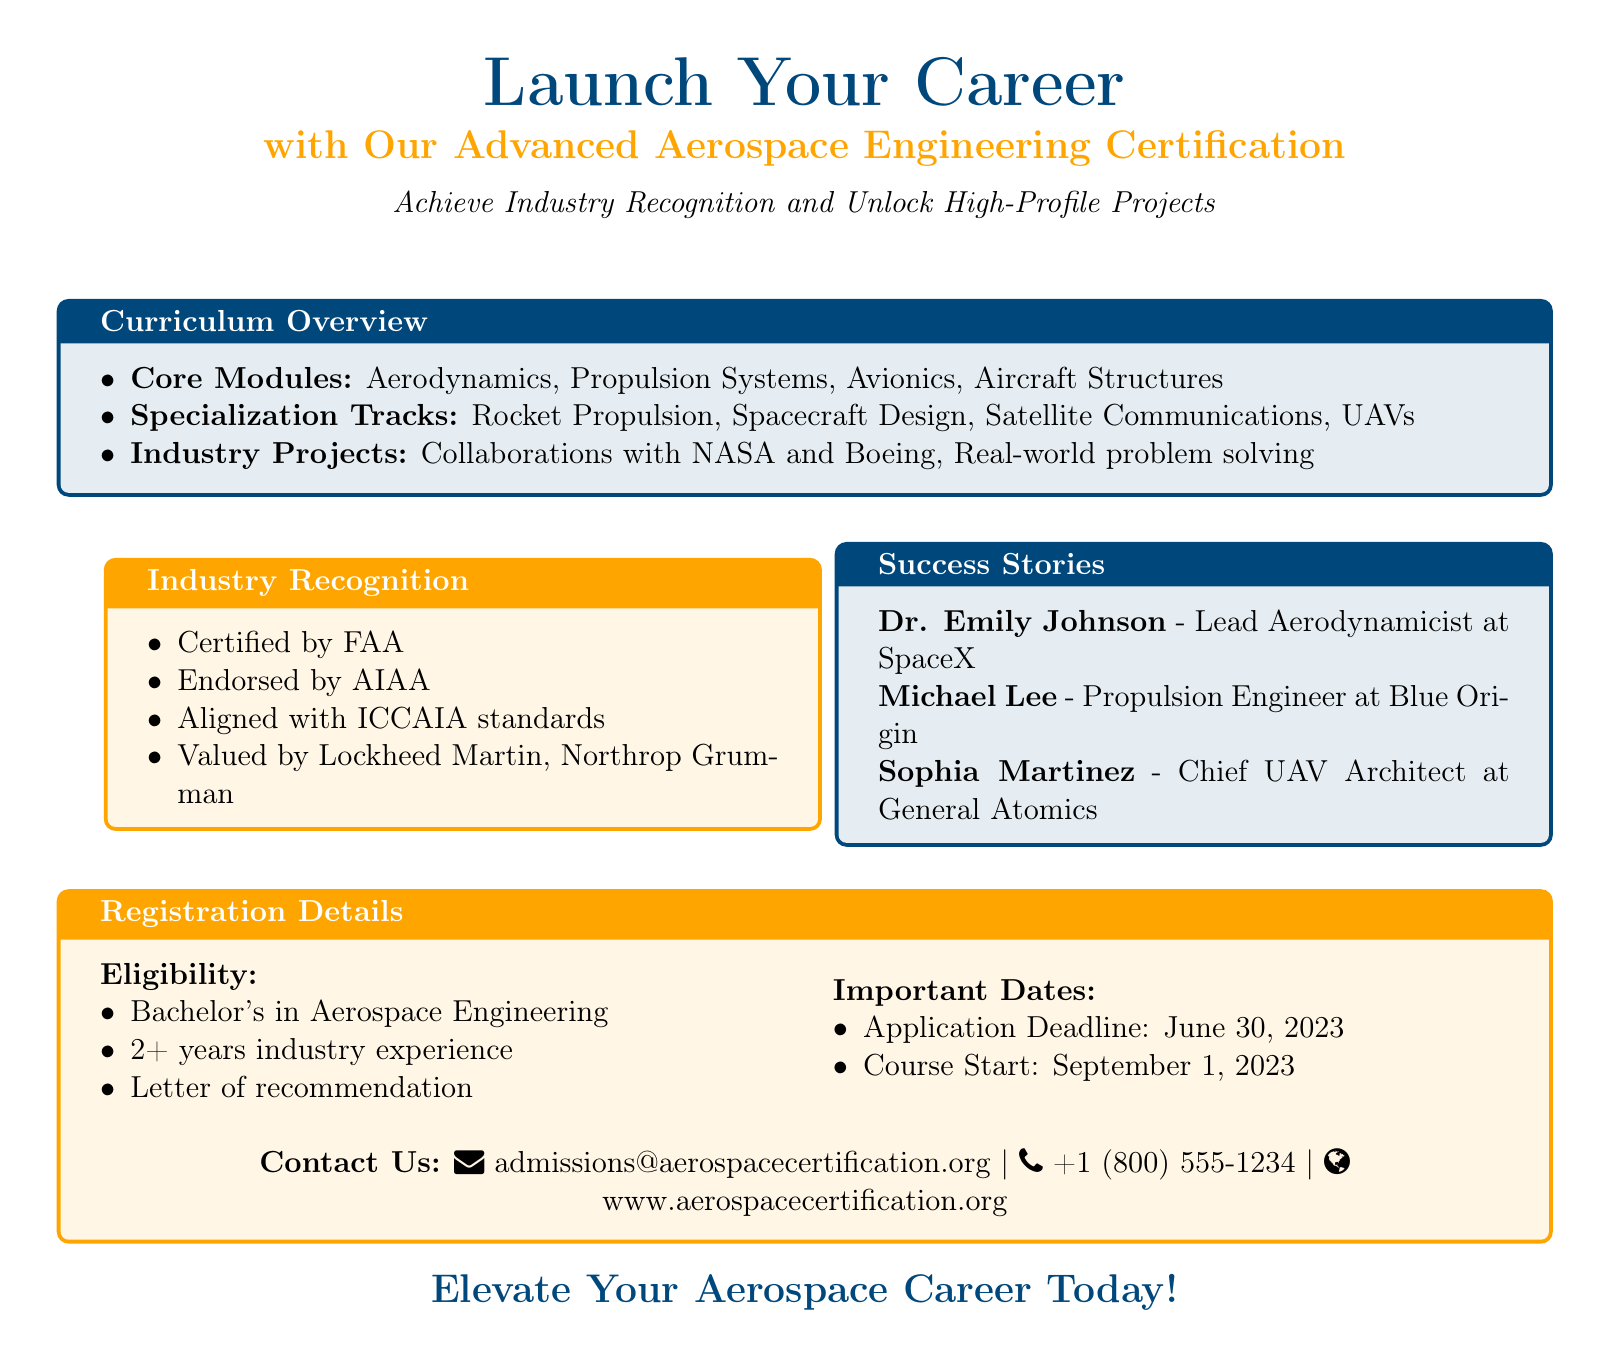What are the core modules included in the curriculum? The core modules are listed under the curriculum overview section of the document.
Answer: Aerodynamics, Propulsion Systems, Avionics, Aircraft Structures Who is a success story mentioned in the advertisement? The advertisement specifically highlights individuals who have succeeded after completing the certification program.
Answer: Dr. Emily Johnson Which organization endorses the certification? The industry recognition section of the document mentions organizations that endorse the certification.
Answer: AIAA What is the application deadline for the certification program? The important dates section provides specific timelines for applications and course commencement.
Answer: June 30, 2023 How many years of industry experience is required for eligibility? The eligibility criteria states the experience level needed to apply for the certification.
Answer: 2+ years What is one of the specialization tracks offered? The curriculum overview outlines the specific specialization tracks available for the certification.
Answer: Rocket Propulsion Which company values the certification as stated in the document? The industry recognition section lists companies that value the certification, indicating its relevance in the aerospace field.
Answer: Lockheed Martin What is the course start date? The important dates section includes the start date for the certification program.
Answer: September 1, 2023 